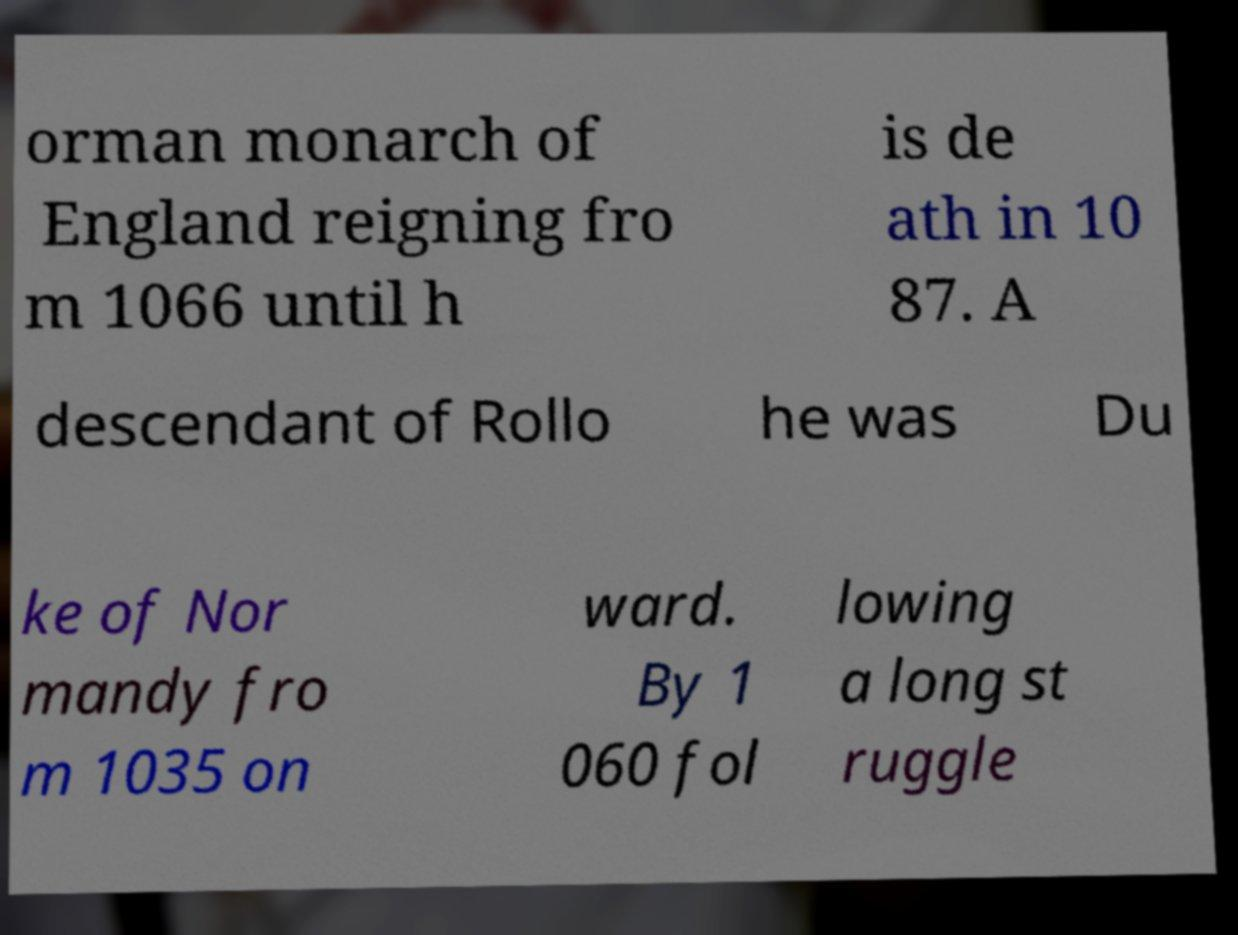Can you accurately transcribe the text from the provided image for me? orman monarch of England reigning fro m 1066 until h is de ath in 10 87. A descendant of Rollo he was Du ke of Nor mandy fro m 1035 on ward. By 1 060 fol lowing a long st ruggle 